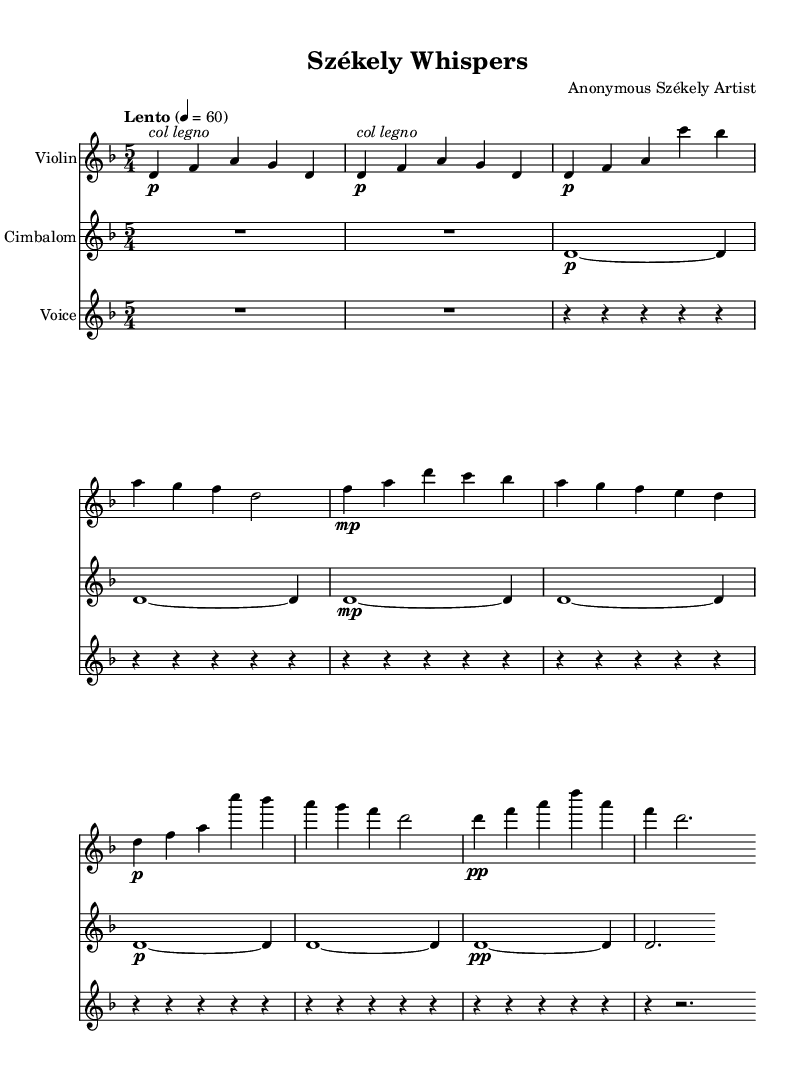What is the key signature of this piece? The key signature shows two flats (B♭ and E♭), which indicates that the piece is in D minor.
Answer: D minor What is the time signature? The time signature at the beginning of the sheet music is written as 5/4, indicating that there are five beats in each measure.
Answer: 5/4 What is the tempo marking of the piece? The tempo marking is noted as "Lento," which means slow, and the metronome marking shows a speed of 60 beats per minute.
Answer: Lento, 60 How many sections does the piece have? The piece is structured into four distinct sections: Introduction, Section A, Section B, and Coda, which contributes to its experimental form.
Answer: Four In which instrument's part is the expression "col legno" found? The expression "col legno" is indicated in the part for the Violin, which instructs the player to use the wood of the bow for a unique sound effect.
Answer: Violin What dynamics are indicated at the beginning of the Cimbalom part? The Cimbalom part begins with a dynamic marking of "p" for piano, indicating that it should be played softly.
Answer: Piano What vocal technique is utilized in the voice part? The voice part primarily features rests throughout, indicating a focus on silence rather than sung phrases, which emphasizes the minimalist approach of the piece.
Answer: Rests 